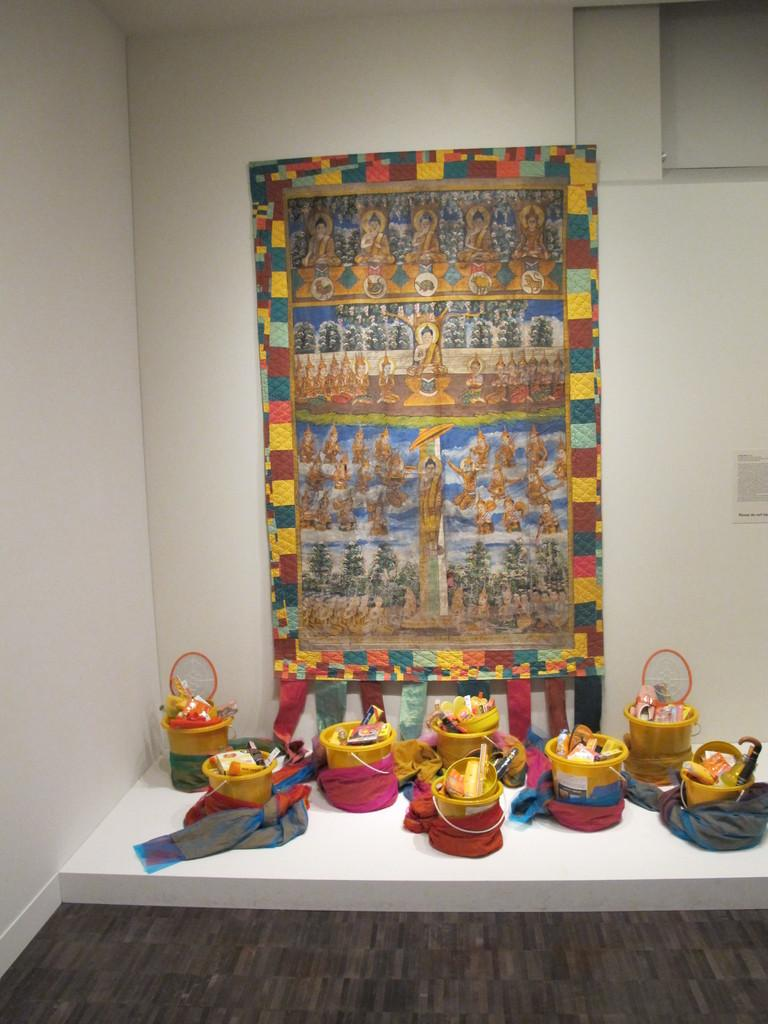What type of structure can be seen in the image? There is a wall in the image. What objects are present in the image that might be used for holding or carrying liquids? There are buckets in the image. What type of object is in the image that might be used for displaying or supporting other objects? There is a frame in the image. What invention is being demonstrated in the image? There is no invention being demonstrated in the image; it only features a wall, buckets, and a frame. How does the wall blow in the wind in the image? The wall does not blow in the wind in the image; it is stationary. 